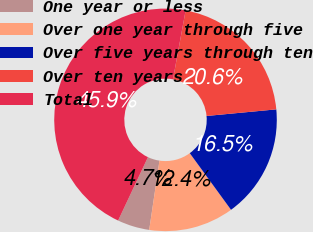Convert chart to OTSL. <chart><loc_0><loc_0><loc_500><loc_500><pie_chart><fcel>One year or less<fcel>Over one year through five<fcel>Over five years through ten<fcel>Over ten years<fcel>Total<nl><fcel>4.66%<fcel>12.36%<fcel>16.48%<fcel>20.6%<fcel>45.89%<nl></chart> 